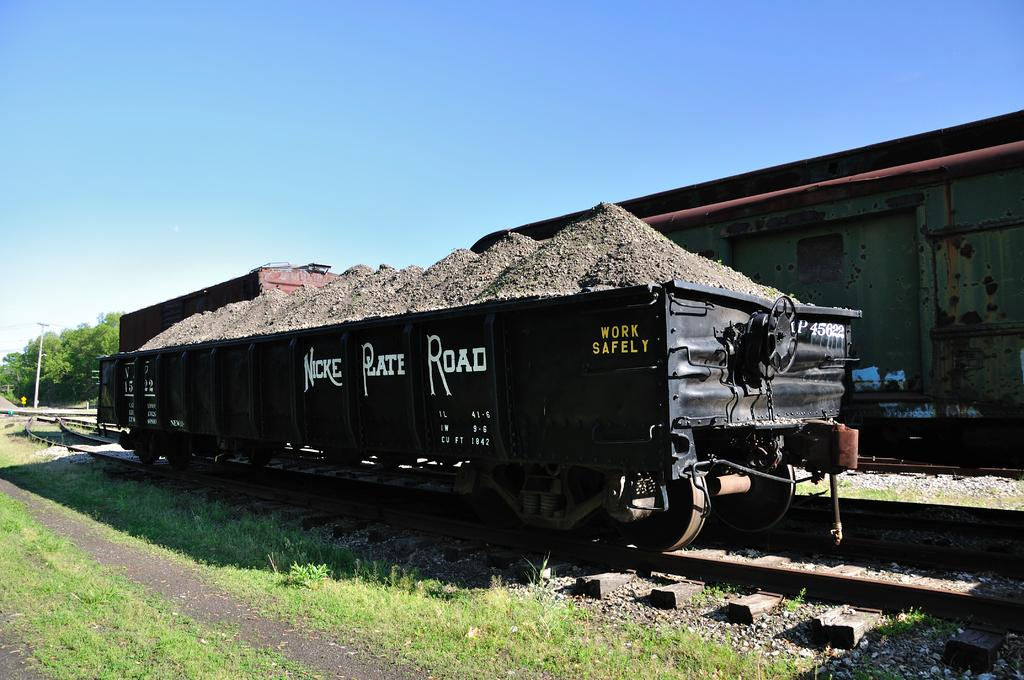What type of train is in the image? There is a goods train in the image. Where is the train located? The train is on a track. What type of vegetation can be seen in the image? There are trees and plants in the image. What is on the ground in the image? There is grass on the ground in the image. What type of van can be seen driving through the dirt in the image? There is no van or dirt present in the image; it features a goods train on a track with trees, plants, and grass. 